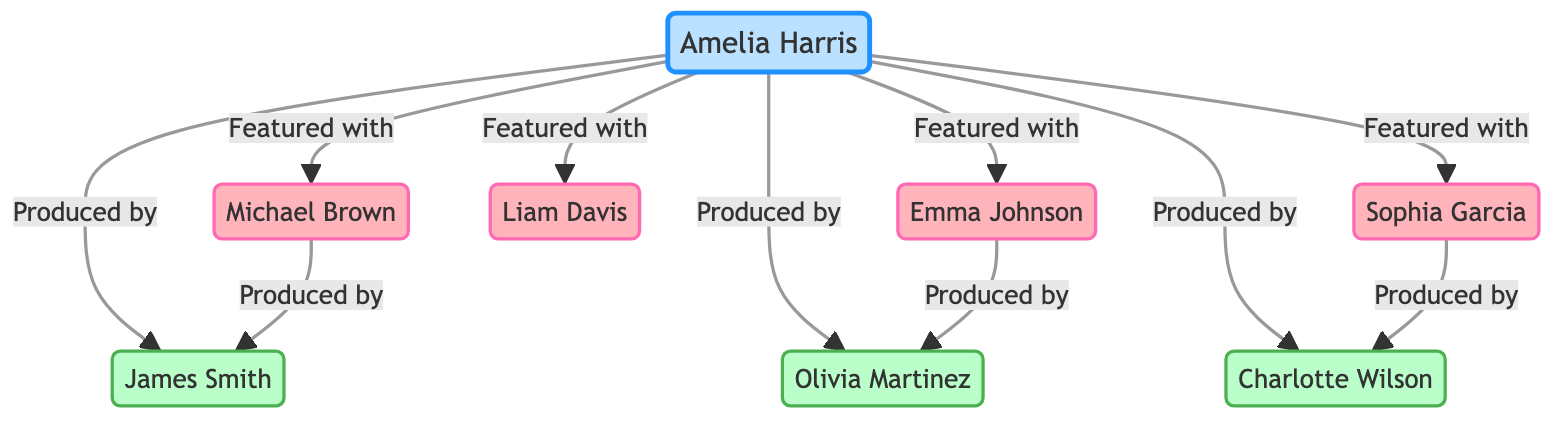What is the total number of nodes in the diagram? The diagram consists of eight nodes, which include Amelia Harris, four featured artists, and three producers.
Answer: 8 Who are the producers associated with Amelia Harris? The diagram shows that Amelia Harris has three connections denoting producers: James Smith, Olivia Martinez, and Charlotte Wilson.
Answer: James Smith, Olivia Martinez, Charlotte Wilson How many featured artists collaborated with Amelia Harris? There are four connections originating from Amelia Harris to featured artists: Michael Brown, Emma Johnson, Liam Davis, and Sophia Garcia.
Answer: 4 Which featured artist collaborated with James Smith? The connection between Michael Brown and James Smith shows that Michael Brown was produced by James Smith, indicating that he is the featured artist related to this producer.
Answer: Michael Brown How many collaborations involve Charlotte Wilson? Charlotte Wilson is connected to both Amelia Harris and Sophia Garcia, indicating two edges related to her role as a producer.
Answer: 2 Which artist is connected to Olivia Martinez? The diagram indicates that Emma Johnson has a direct connection to Olivia Martinez, showing her as a featured artist that collaborated with this producer.
Answer: Emma Johnson What type of relationships does Amelia Harris have with her collaborators? Amelia Harris has "Produced by" relationships with three producers and "Featured with" relationships with four featured artists, indicating diverse collaborations in her career.
Answer: Produced by, Featured with Identify the number of edges in the diagram. The diagram illustrates ten edges, representing all the connections and collaborations involving Amelia Harris and other artists and producers.
Answer: 10 What is the role of Sofia Garcia in relation to Amelia Harris? The relationship labeled "Featured with" from Amelia Harris to Sophia Garcia indicates that Sophia Garcia is a featured artist collaborating with her.
Answer: Featured Artist 